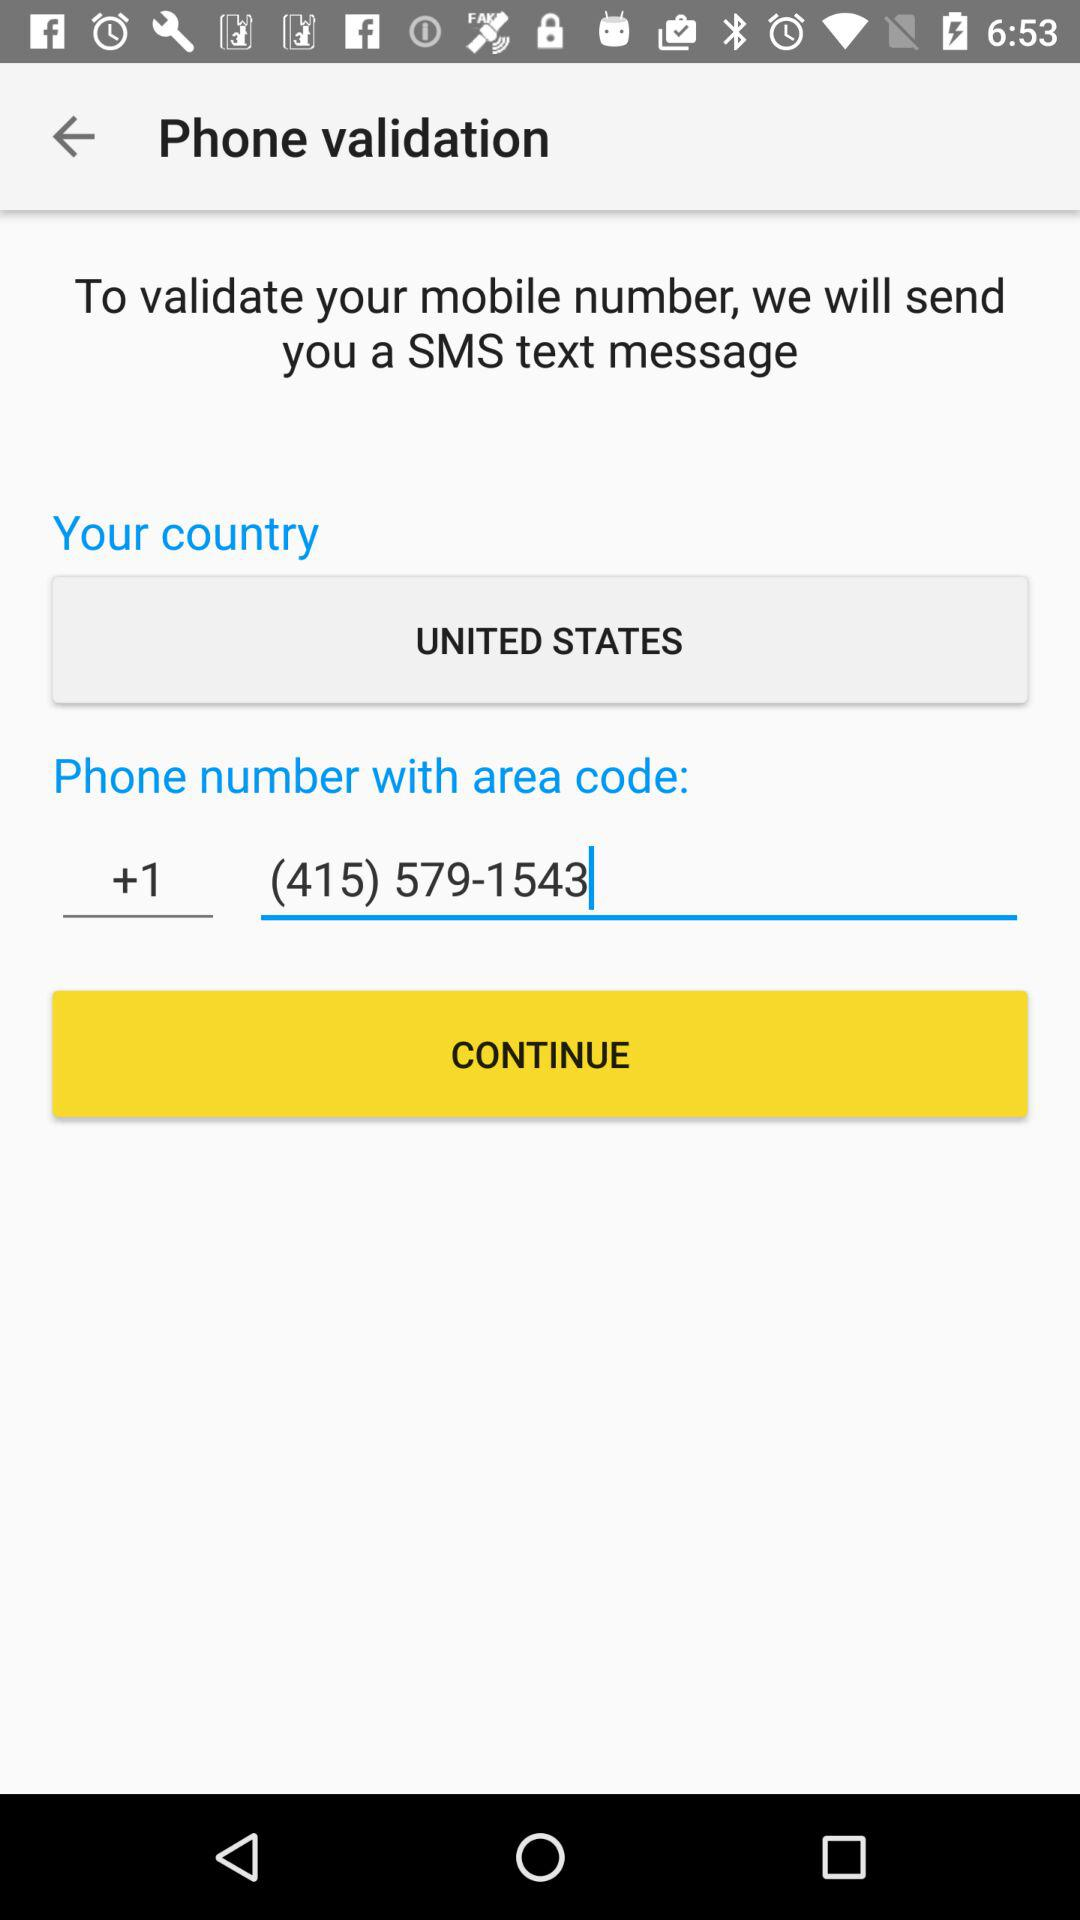What is the country name? The country name is the United States. 